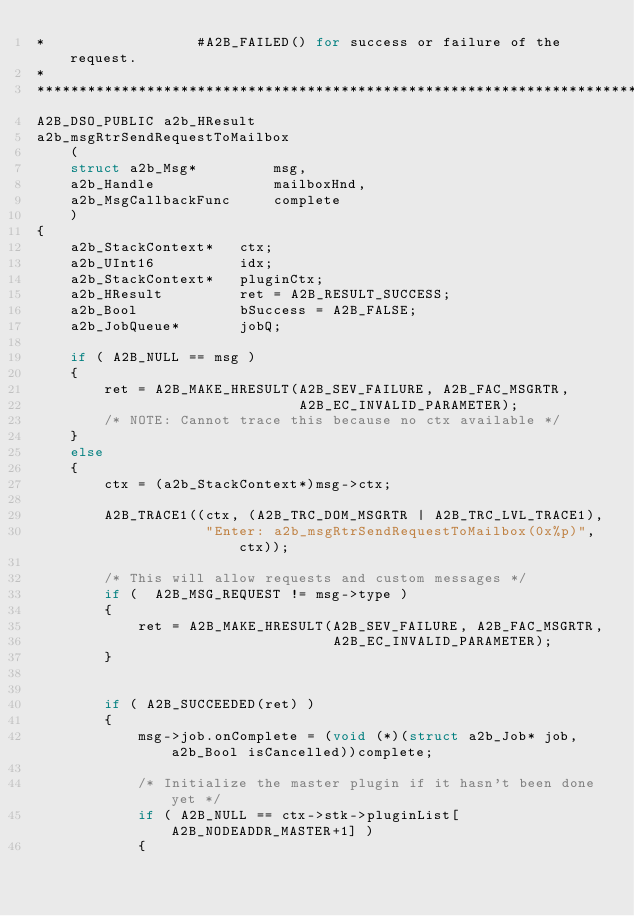<code> <loc_0><loc_0><loc_500><loc_500><_C_>*                  #A2B_FAILED() for success or failure of the request.
*
******************************************************************************/
A2B_DSO_PUBLIC a2b_HResult
a2b_msgRtrSendRequestToMailbox
    (
    struct a2b_Msg*         msg,
    a2b_Handle              mailboxHnd,
    a2b_MsgCallbackFunc     complete
    )
{
    a2b_StackContext*   ctx;
    a2b_UInt16          idx;
    a2b_StackContext*   pluginCtx;
    a2b_HResult         ret = A2B_RESULT_SUCCESS;
    a2b_Bool            bSuccess = A2B_FALSE;
    a2b_JobQueue*       jobQ;

    if ( A2B_NULL == msg )
    {
        ret = A2B_MAKE_HRESULT(A2B_SEV_FAILURE, A2B_FAC_MSGRTR,
                               A2B_EC_INVALID_PARAMETER);
        /* NOTE: Cannot trace this because no ctx available */
    }
    else
    {
        ctx = (a2b_StackContext*)msg->ctx;

        A2B_TRACE1((ctx, (A2B_TRC_DOM_MSGRTR | A2B_TRC_LVL_TRACE1),
                    "Enter: a2b_msgRtrSendRequestToMailbox(0x%p)", ctx));

        /* This will allow requests and custom messages */
        if (  A2B_MSG_REQUEST != msg->type )
        {
            ret = A2B_MAKE_HRESULT(A2B_SEV_FAILURE, A2B_FAC_MSGRTR, 
                                   A2B_EC_INVALID_PARAMETER);
        }


        if ( A2B_SUCCEEDED(ret) )
        {
            msg->job.onComplete = (void (*)(struct a2b_Job* job, a2b_Bool isCancelled))complete;

            /* Initialize the master plugin if it hasn't been done yet */
            if ( A2B_NULL == ctx->stk->pluginList[A2B_NODEADDR_MASTER+1] )
            {</code> 